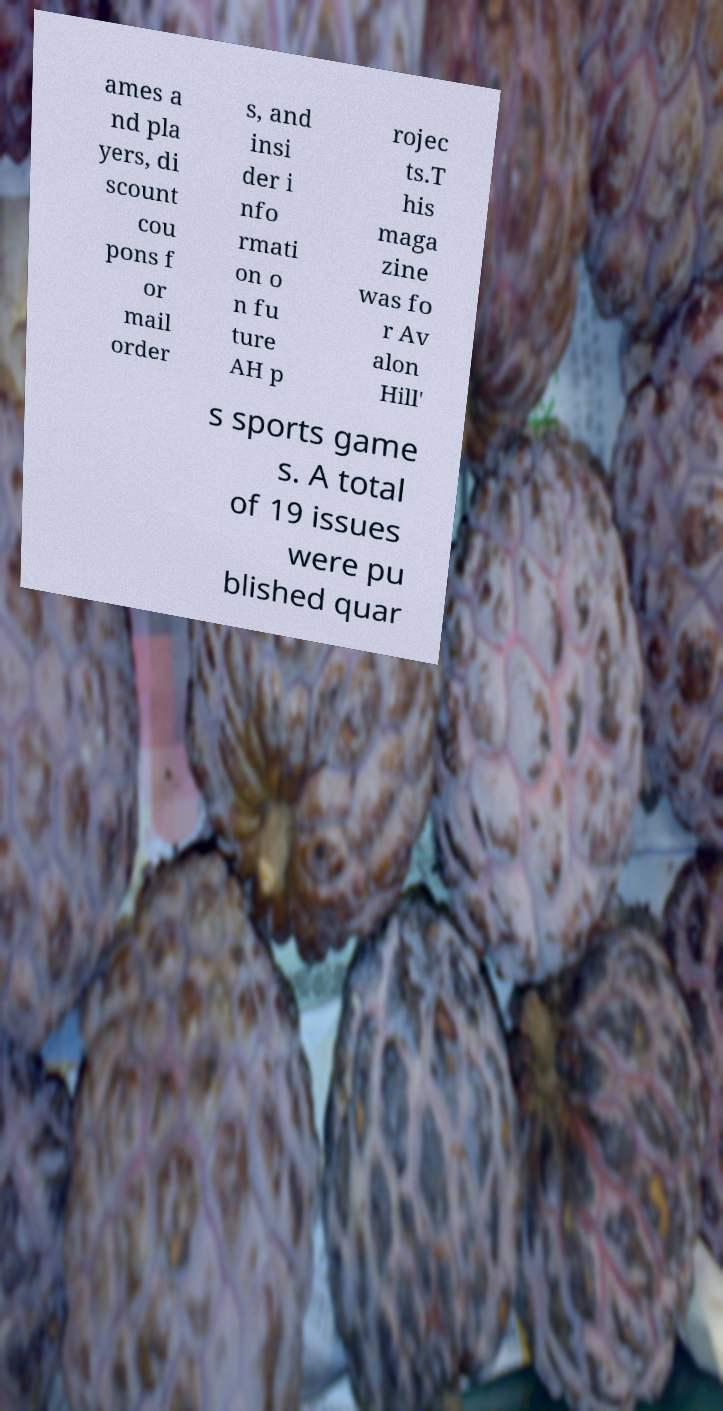Can you accurately transcribe the text from the provided image for me? ames a nd pla yers, di scount cou pons f or mail order s, and insi der i nfo rmati on o n fu ture AH p rojec ts.T his maga zine was fo r Av alon Hill' s sports game s. A total of 19 issues were pu blished quar 